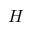<formula> <loc_0><loc_0><loc_500><loc_500>H</formula> 